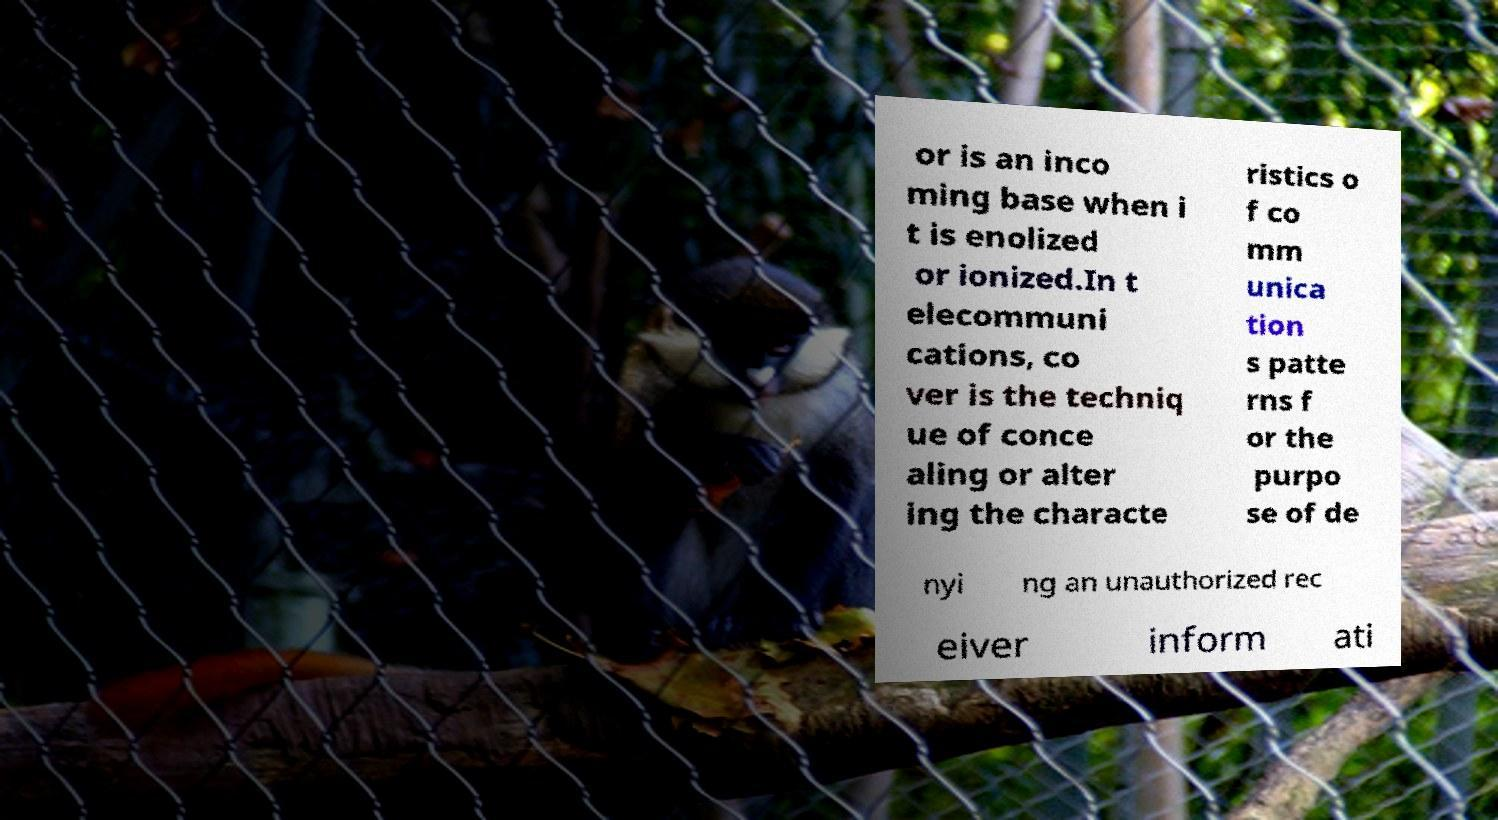What messages or text are displayed in this image? I need them in a readable, typed format. or is an inco ming base when i t is enolized or ionized.In t elecommuni cations, co ver is the techniq ue of conce aling or alter ing the characte ristics o f co mm unica tion s patte rns f or the purpo se of de nyi ng an unauthorized rec eiver inform ati 